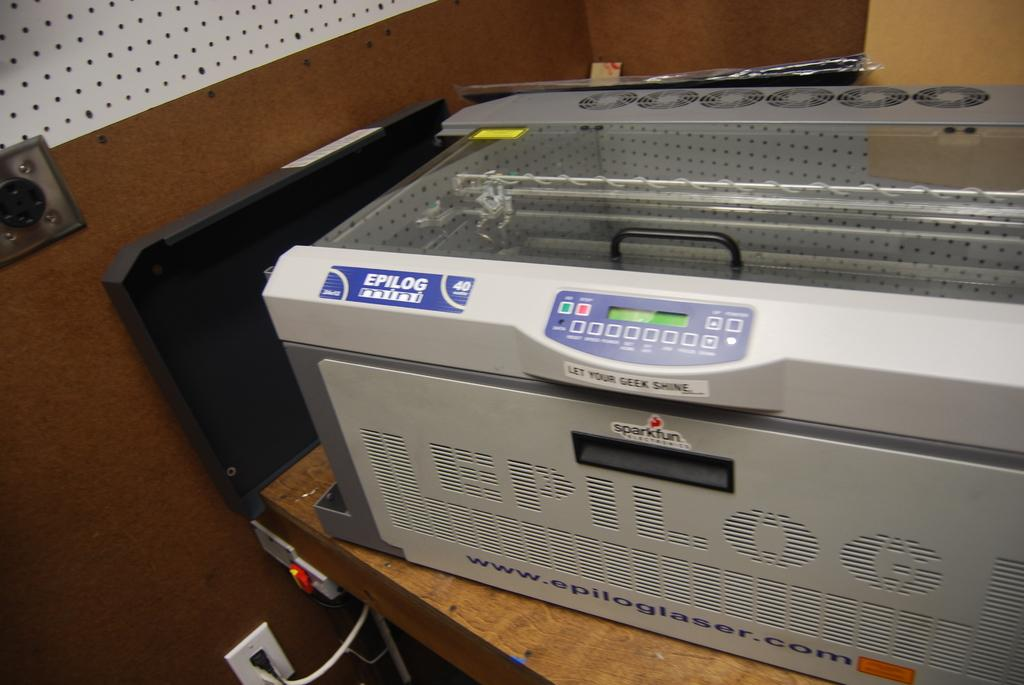<image>
Write a terse but informative summary of the picture. Printer with a blue label on it that says Epilog. 